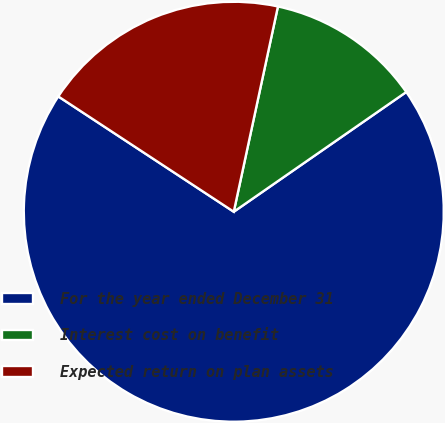Convert chart to OTSL. <chart><loc_0><loc_0><loc_500><loc_500><pie_chart><fcel>For the year ended December 31<fcel>Interest cost on benefit<fcel>Expected return on plan assets<nl><fcel>68.91%<fcel>11.97%<fcel>19.12%<nl></chart> 